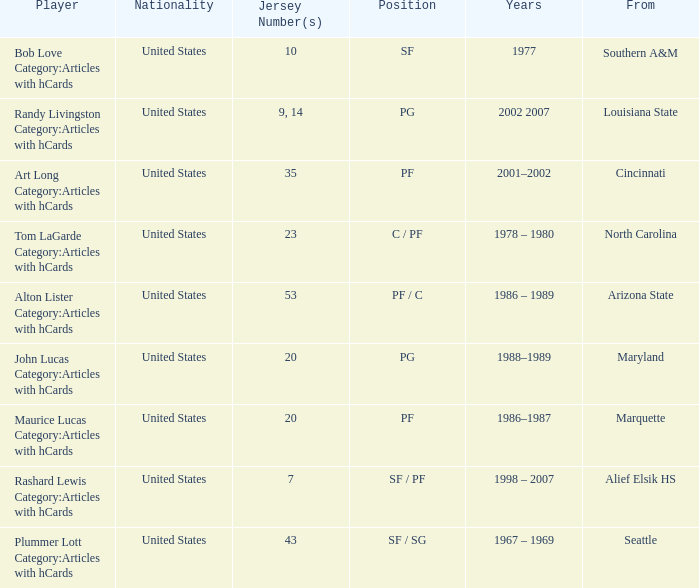Bob Love Category:Articles with hCards is from where? Southern A&M. 